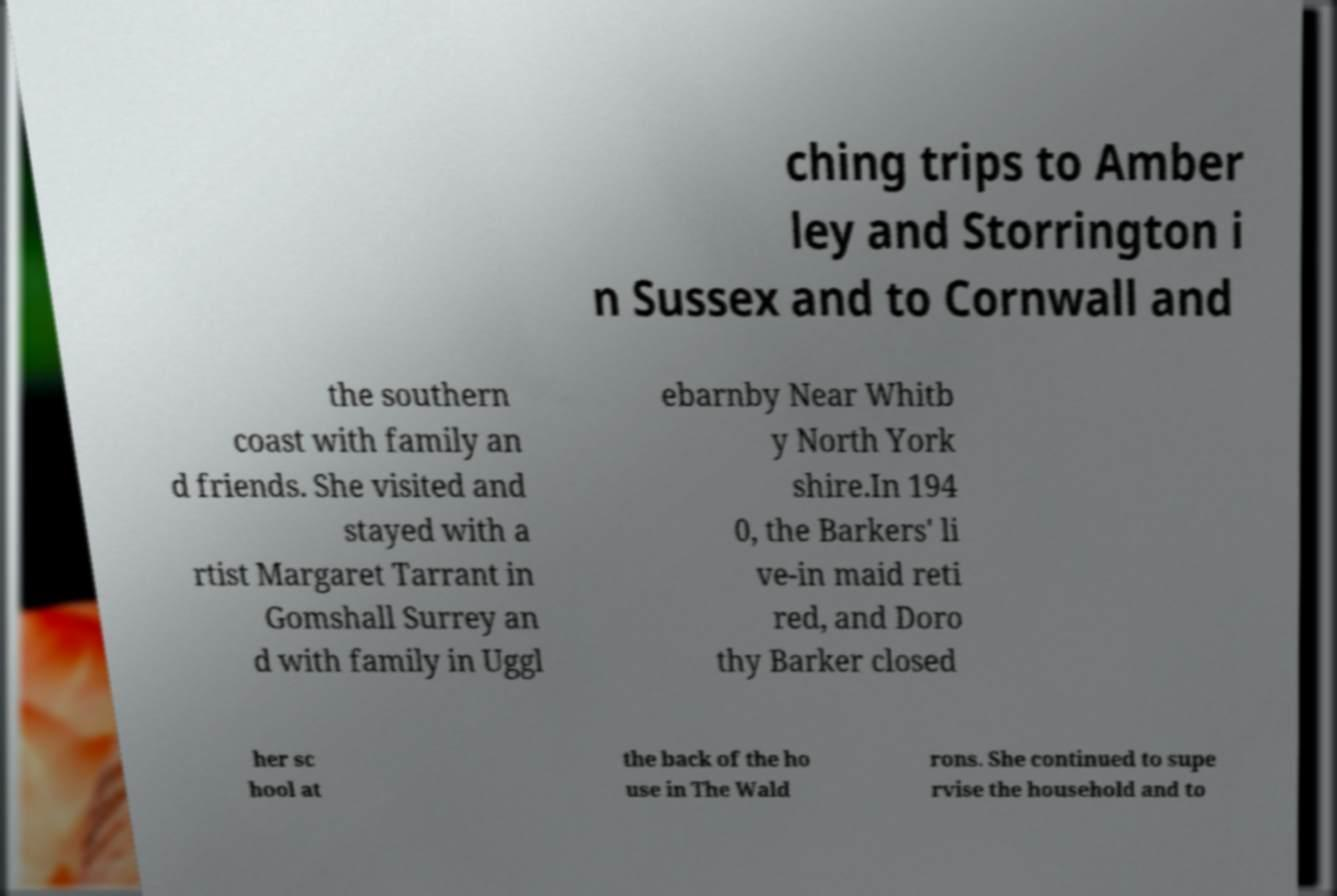Can you read and provide the text displayed in the image?This photo seems to have some interesting text. Can you extract and type it out for me? ching trips to Amber ley and Storrington i n Sussex and to Cornwall and the southern coast with family an d friends. She visited and stayed with a rtist Margaret Tarrant in Gomshall Surrey an d with family in Uggl ebarnby Near Whitb y North York shire.In 194 0, the Barkers' li ve-in maid reti red, and Doro thy Barker closed her sc hool at the back of the ho use in The Wald rons. She continued to supe rvise the household and to 